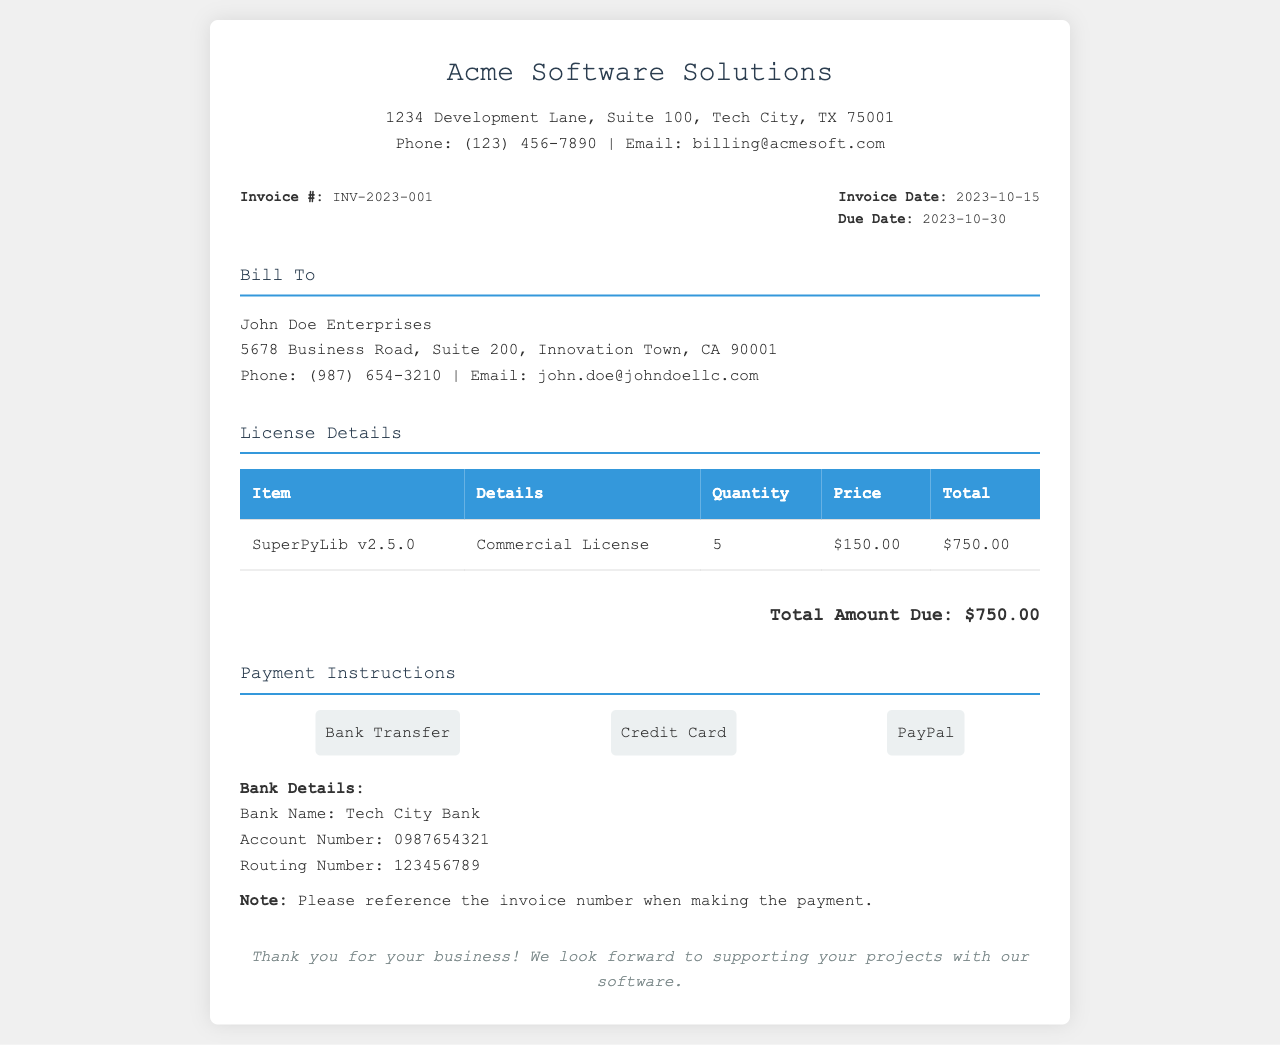what is the invoice number? The invoice number is prominently displayed near the top of the document.
Answer: INV-2023-001 who is billed in this invoice? The "Bill To" section clearly states the name of the entity billed.
Answer: John Doe Enterprises what is the quantity of licenses purchased? The quantity is listed in the License Details table under "Quantity".
Answer: 5 what is the price per license? The price per license can be found in the License Details table under "Price".
Answer: $150.00 what is the total amount due? The total amount due is stated at the bottom of the License Details section.
Answer: $750.00 what is the due date for this invoice? The due date is clearly shown under the invoice details section.
Answer: 2023-10-30 what type of license is purchased? The type of license is described in the License Details table.
Answer: Commercial License how many payment methods are mentioned? The "Payment Instructions" section lists the available payment methods.
Answer: 3 who should be contacted for billing inquiries? The company's contact information is listed in the header section of the document.
Answer: billing@acmesoft.com 